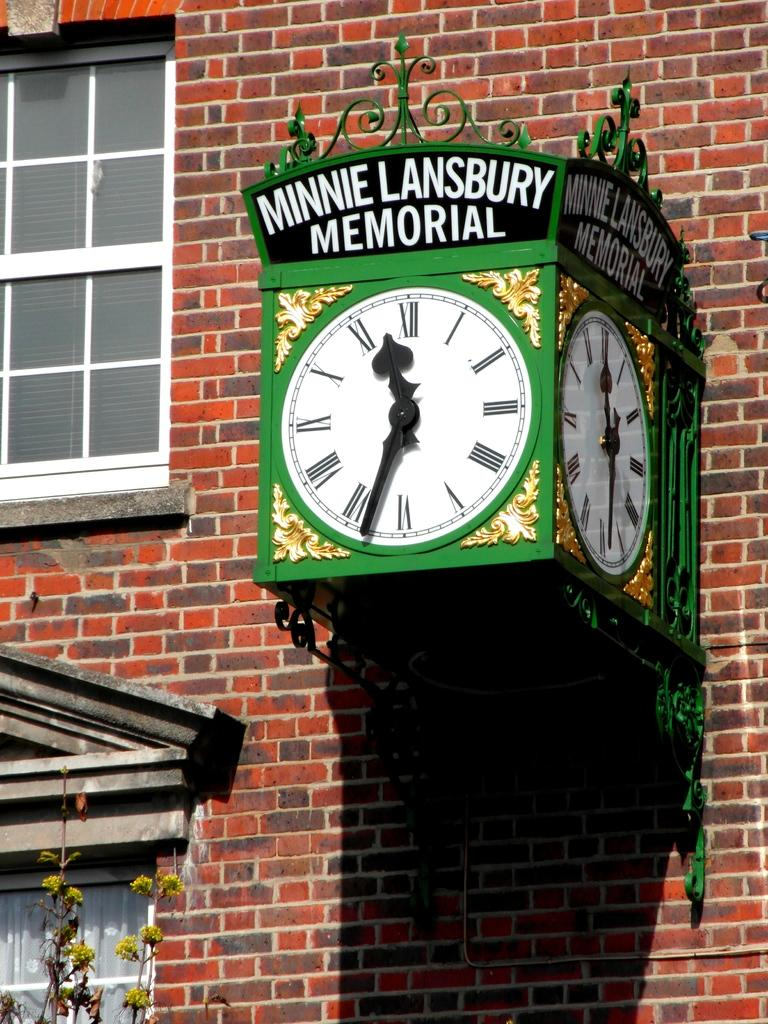<image>
Summarize the visual content of the image. Minnie Lansbury Memorial clock on the side of a brick wall. 